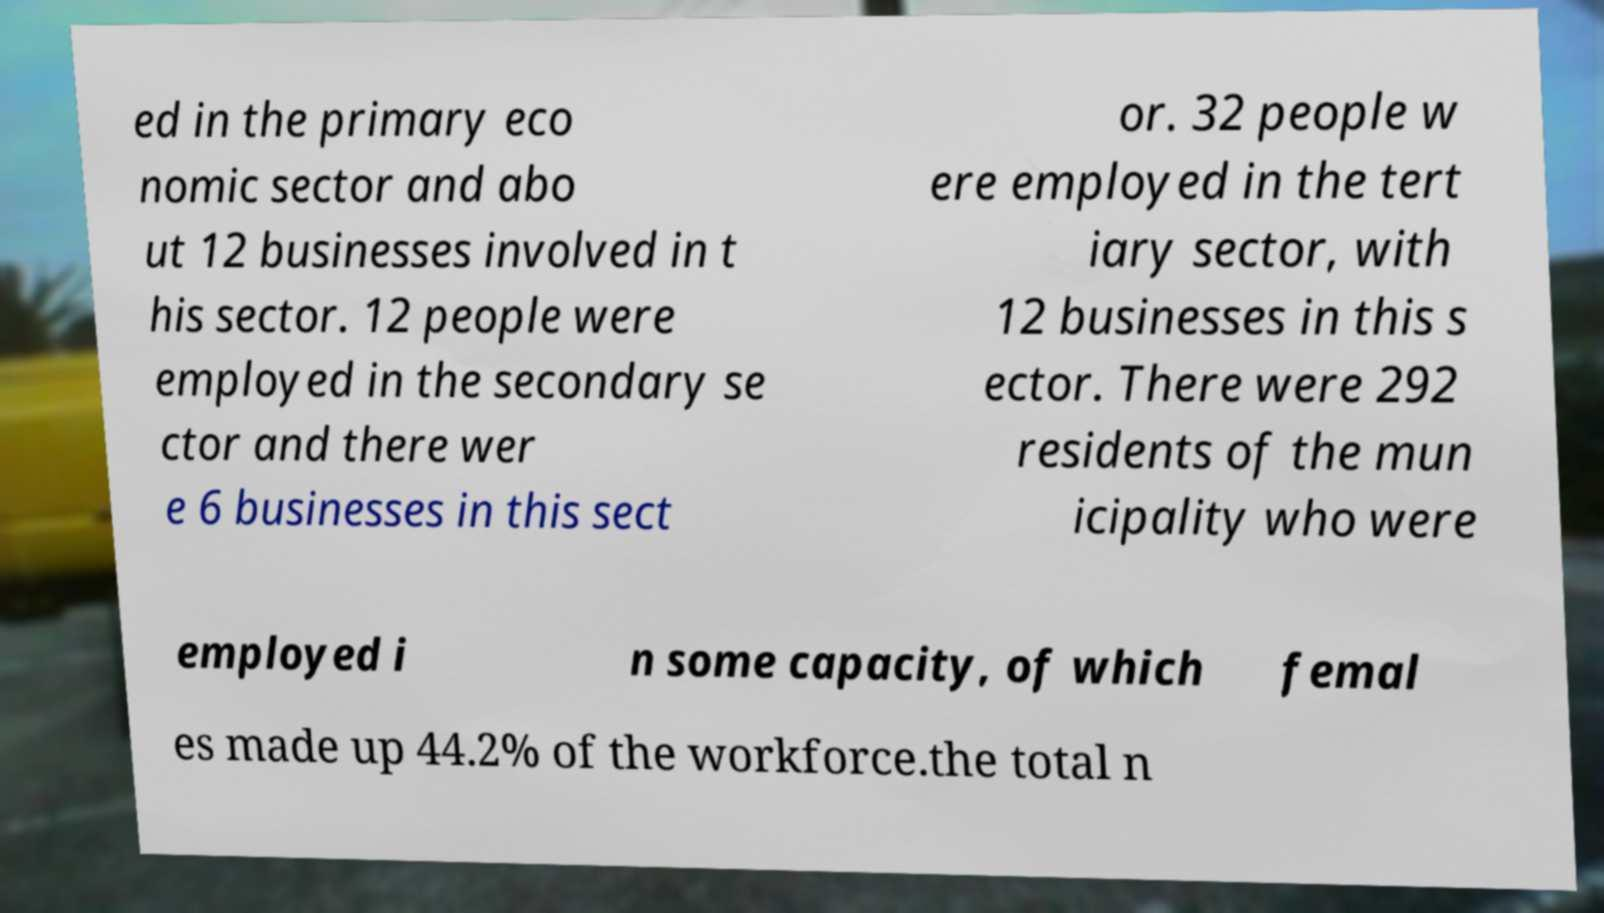Please identify and transcribe the text found in this image. ed in the primary eco nomic sector and abo ut 12 businesses involved in t his sector. 12 people were employed in the secondary se ctor and there wer e 6 businesses in this sect or. 32 people w ere employed in the tert iary sector, with 12 businesses in this s ector. There were 292 residents of the mun icipality who were employed i n some capacity, of which femal es made up 44.2% of the workforce.the total n 